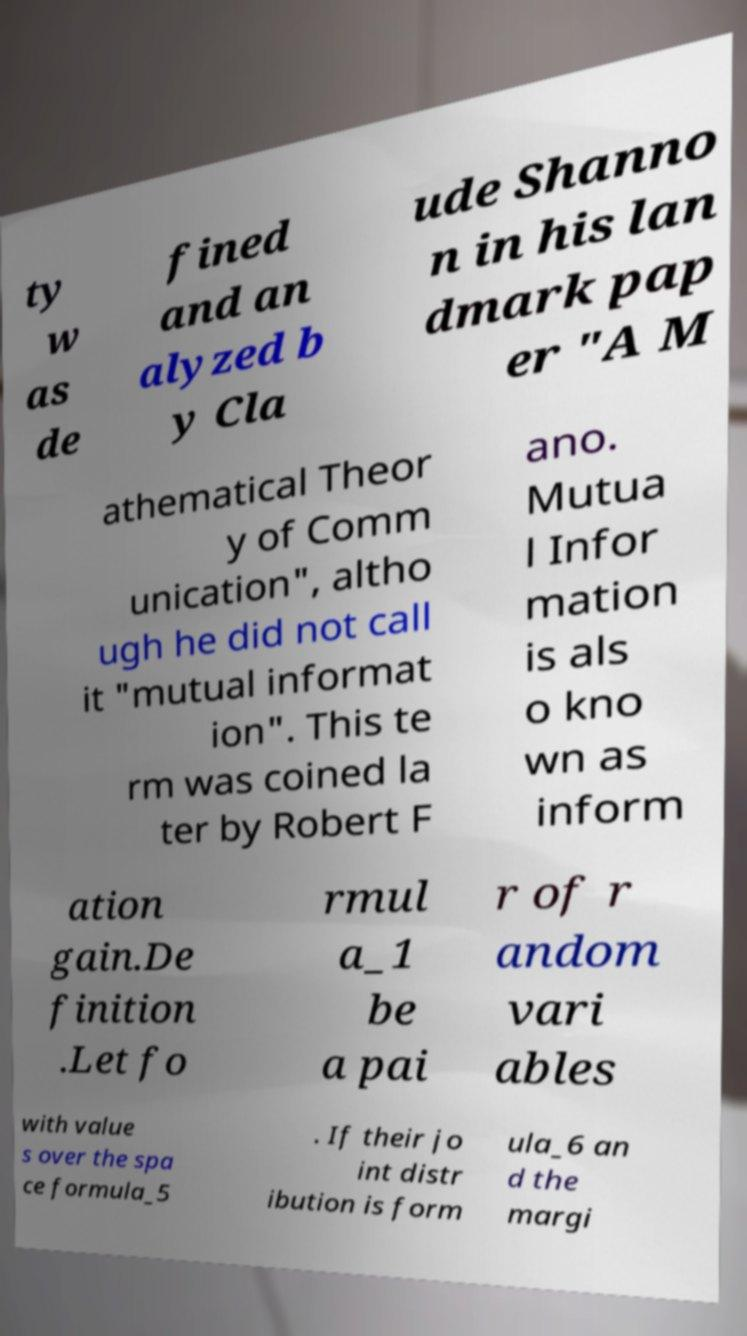Can you read and provide the text displayed in the image?This photo seems to have some interesting text. Can you extract and type it out for me? ty w as de fined and an alyzed b y Cla ude Shanno n in his lan dmark pap er "A M athematical Theor y of Comm unication", altho ugh he did not call it "mutual informat ion". This te rm was coined la ter by Robert F ano. Mutua l Infor mation is als o kno wn as inform ation gain.De finition .Let fo rmul a_1 be a pai r of r andom vari ables with value s over the spa ce formula_5 . If their jo int distr ibution is form ula_6 an d the margi 